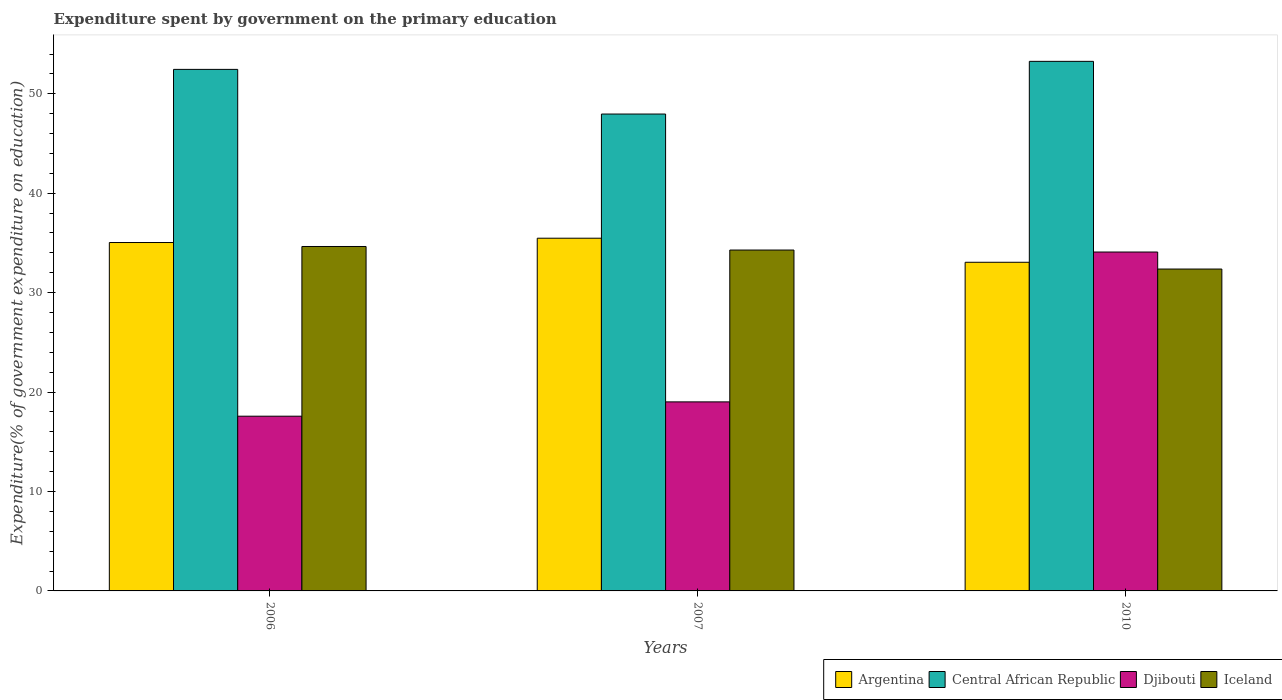How many groups of bars are there?
Keep it short and to the point. 3. Are the number of bars per tick equal to the number of legend labels?
Ensure brevity in your answer.  Yes. How many bars are there on the 2nd tick from the right?
Provide a succinct answer. 4. What is the expenditure spent by government on the primary education in Argentina in 2007?
Offer a very short reply. 35.48. Across all years, what is the maximum expenditure spent by government on the primary education in Argentina?
Provide a short and direct response. 35.48. Across all years, what is the minimum expenditure spent by government on the primary education in Argentina?
Give a very brief answer. 33.05. In which year was the expenditure spent by government on the primary education in Iceland maximum?
Provide a succinct answer. 2006. What is the total expenditure spent by government on the primary education in Central African Republic in the graph?
Provide a succinct answer. 153.69. What is the difference between the expenditure spent by government on the primary education in Argentina in 2006 and that in 2010?
Offer a terse response. 1.99. What is the difference between the expenditure spent by government on the primary education in Djibouti in 2010 and the expenditure spent by government on the primary education in Central African Republic in 2006?
Make the answer very short. -18.37. What is the average expenditure spent by government on the primary education in Iceland per year?
Keep it short and to the point. 33.77. In the year 2006, what is the difference between the expenditure spent by government on the primary education in Argentina and expenditure spent by government on the primary education in Iceland?
Provide a succinct answer. 0.4. What is the ratio of the expenditure spent by government on the primary education in Central African Republic in 2006 to that in 2007?
Ensure brevity in your answer.  1.09. Is the expenditure spent by government on the primary education in Argentina in 2006 less than that in 2010?
Offer a very short reply. No. Is the difference between the expenditure spent by government on the primary education in Argentina in 2007 and 2010 greater than the difference between the expenditure spent by government on the primary education in Iceland in 2007 and 2010?
Provide a succinct answer. Yes. What is the difference between the highest and the second highest expenditure spent by government on the primary education in Argentina?
Make the answer very short. 0.43. What is the difference between the highest and the lowest expenditure spent by government on the primary education in Djibouti?
Your answer should be very brief. 16.51. Is the sum of the expenditure spent by government on the primary education in Central African Republic in 2006 and 2010 greater than the maximum expenditure spent by government on the primary education in Djibouti across all years?
Your answer should be very brief. Yes. What does the 2nd bar from the left in 2010 represents?
Your response must be concise. Central African Republic. What does the 4th bar from the right in 2007 represents?
Your response must be concise. Argentina. How many years are there in the graph?
Your answer should be compact. 3. What is the difference between two consecutive major ticks on the Y-axis?
Provide a short and direct response. 10. Are the values on the major ticks of Y-axis written in scientific E-notation?
Give a very brief answer. No. Does the graph contain grids?
Provide a succinct answer. No. How many legend labels are there?
Provide a succinct answer. 4. What is the title of the graph?
Make the answer very short. Expenditure spent by government on the primary education. Does "Greenland" appear as one of the legend labels in the graph?
Your answer should be very brief. No. What is the label or title of the X-axis?
Ensure brevity in your answer.  Years. What is the label or title of the Y-axis?
Offer a terse response. Expenditure(% of government expenditure on education). What is the Expenditure(% of government expenditure on education) in Argentina in 2006?
Your answer should be compact. 35.04. What is the Expenditure(% of government expenditure on education) in Central African Republic in 2006?
Offer a terse response. 52.46. What is the Expenditure(% of government expenditure on education) in Djibouti in 2006?
Offer a terse response. 17.57. What is the Expenditure(% of government expenditure on education) of Iceland in 2006?
Ensure brevity in your answer.  34.64. What is the Expenditure(% of government expenditure on education) in Argentina in 2007?
Ensure brevity in your answer.  35.48. What is the Expenditure(% of government expenditure on education) of Central African Republic in 2007?
Keep it short and to the point. 47.96. What is the Expenditure(% of government expenditure on education) of Djibouti in 2007?
Offer a very short reply. 19.01. What is the Expenditure(% of government expenditure on education) in Iceland in 2007?
Your answer should be very brief. 34.29. What is the Expenditure(% of government expenditure on education) of Argentina in 2010?
Offer a very short reply. 33.05. What is the Expenditure(% of government expenditure on education) of Central African Republic in 2010?
Your answer should be very brief. 53.26. What is the Expenditure(% of government expenditure on education) of Djibouti in 2010?
Give a very brief answer. 34.09. What is the Expenditure(% of government expenditure on education) of Iceland in 2010?
Offer a very short reply. 32.38. Across all years, what is the maximum Expenditure(% of government expenditure on education) in Argentina?
Ensure brevity in your answer.  35.48. Across all years, what is the maximum Expenditure(% of government expenditure on education) of Central African Republic?
Your response must be concise. 53.26. Across all years, what is the maximum Expenditure(% of government expenditure on education) of Djibouti?
Your answer should be very brief. 34.09. Across all years, what is the maximum Expenditure(% of government expenditure on education) in Iceland?
Your answer should be compact. 34.64. Across all years, what is the minimum Expenditure(% of government expenditure on education) in Argentina?
Your answer should be very brief. 33.05. Across all years, what is the minimum Expenditure(% of government expenditure on education) of Central African Republic?
Provide a succinct answer. 47.96. Across all years, what is the minimum Expenditure(% of government expenditure on education) in Djibouti?
Offer a very short reply. 17.57. Across all years, what is the minimum Expenditure(% of government expenditure on education) in Iceland?
Ensure brevity in your answer.  32.38. What is the total Expenditure(% of government expenditure on education) of Argentina in the graph?
Keep it short and to the point. 103.57. What is the total Expenditure(% of government expenditure on education) in Central African Republic in the graph?
Offer a terse response. 153.69. What is the total Expenditure(% of government expenditure on education) in Djibouti in the graph?
Provide a short and direct response. 70.67. What is the total Expenditure(% of government expenditure on education) in Iceland in the graph?
Your answer should be compact. 101.3. What is the difference between the Expenditure(% of government expenditure on education) in Argentina in 2006 and that in 2007?
Make the answer very short. -0.43. What is the difference between the Expenditure(% of government expenditure on education) of Central African Republic in 2006 and that in 2007?
Provide a succinct answer. 4.49. What is the difference between the Expenditure(% of government expenditure on education) of Djibouti in 2006 and that in 2007?
Provide a succinct answer. -1.44. What is the difference between the Expenditure(% of government expenditure on education) of Iceland in 2006 and that in 2007?
Provide a short and direct response. 0.36. What is the difference between the Expenditure(% of government expenditure on education) in Argentina in 2006 and that in 2010?
Ensure brevity in your answer.  1.99. What is the difference between the Expenditure(% of government expenditure on education) in Central African Republic in 2006 and that in 2010?
Give a very brief answer. -0.81. What is the difference between the Expenditure(% of government expenditure on education) of Djibouti in 2006 and that in 2010?
Ensure brevity in your answer.  -16.51. What is the difference between the Expenditure(% of government expenditure on education) in Iceland in 2006 and that in 2010?
Offer a terse response. 2.27. What is the difference between the Expenditure(% of government expenditure on education) in Argentina in 2007 and that in 2010?
Keep it short and to the point. 2.42. What is the difference between the Expenditure(% of government expenditure on education) in Central African Republic in 2007 and that in 2010?
Ensure brevity in your answer.  -5.3. What is the difference between the Expenditure(% of government expenditure on education) in Djibouti in 2007 and that in 2010?
Your answer should be compact. -15.07. What is the difference between the Expenditure(% of government expenditure on education) in Iceland in 2007 and that in 2010?
Your answer should be very brief. 1.91. What is the difference between the Expenditure(% of government expenditure on education) in Argentina in 2006 and the Expenditure(% of government expenditure on education) in Central African Republic in 2007?
Provide a succinct answer. -12.92. What is the difference between the Expenditure(% of government expenditure on education) of Argentina in 2006 and the Expenditure(% of government expenditure on education) of Djibouti in 2007?
Your response must be concise. 16.03. What is the difference between the Expenditure(% of government expenditure on education) of Argentina in 2006 and the Expenditure(% of government expenditure on education) of Iceland in 2007?
Offer a terse response. 0.76. What is the difference between the Expenditure(% of government expenditure on education) in Central African Republic in 2006 and the Expenditure(% of government expenditure on education) in Djibouti in 2007?
Keep it short and to the point. 33.44. What is the difference between the Expenditure(% of government expenditure on education) in Central African Republic in 2006 and the Expenditure(% of government expenditure on education) in Iceland in 2007?
Make the answer very short. 18.17. What is the difference between the Expenditure(% of government expenditure on education) in Djibouti in 2006 and the Expenditure(% of government expenditure on education) in Iceland in 2007?
Provide a succinct answer. -16.71. What is the difference between the Expenditure(% of government expenditure on education) of Argentina in 2006 and the Expenditure(% of government expenditure on education) of Central African Republic in 2010?
Your response must be concise. -18.22. What is the difference between the Expenditure(% of government expenditure on education) of Argentina in 2006 and the Expenditure(% of government expenditure on education) of Djibouti in 2010?
Offer a terse response. 0.96. What is the difference between the Expenditure(% of government expenditure on education) in Argentina in 2006 and the Expenditure(% of government expenditure on education) in Iceland in 2010?
Offer a terse response. 2.67. What is the difference between the Expenditure(% of government expenditure on education) in Central African Republic in 2006 and the Expenditure(% of government expenditure on education) in Djibouti in 2010?
Offer a very short reply. 18.37. What is the difference between the Expenditure(% of government expenditure on education) of Central African Republic in 2006 and the Expenditure(% of government expenditure on education) of Iceland in 2010?
Make the answer very short. 20.08. What is the difference between the Expenditure(% of government expenditure on education) in Djibouti in 2006 and the Expenditure(% of government expenditure on education) in Iceland in 2010?
Offer a terse response. -14.8. What is the difference between the Expenditure(% of government expenditure on education) in Argentina in 2007 and the Expenditure(% of government expenditure on education) in Central African Republic in 2010?
Your response must be concise. -17.79. What is the difference between the Expenditure(% of government expenditure on education) of Argentina in 2007 and the Expenditure(% of government expenditure on education) of Djibouti in 2010?
Ensure brevity in your answer.  1.39. What is the difference between the Expenditure(% of government expenditure on education) in Argentina in 2007 and the Expenditure(% of government expenditure on education) in Iceland in 2010?
Provide a succinct answer. 3.1. What is the difference between the Expenditure(% of government expenditure on education) in Central African Republic in 2007 and the Expenditure(% of government expenditure on education) in Djibouti in 2010?
Your answer should be very brief. 13.88. What is the difference between the Expenditure(% of government expenditure on education) in Central African Republic in 2007 and the Expenditure(% of government expenditure on education) in Iceland in 2010?
Your answer should be very brief. 15.59. What is the difference between the Expenditure(% of government expenditure on education) of Djibouti in 2007 and the Expenditure(% of government expenditure on education) of Iceland in 2010?
Keep it short and to the point. -13.36. What is the average Expenditure(% of government expenditure on education) of Argentina per year?
Your answer should be very brief. 34.52. What is the average Expenditure(% of government expenditure on education) of Central African Republic per year?
Your response must be concise. 51.23. What is the average Expenditure(% of government expenditure on education) of Djibouti per year?
Provide a succinct answer. 23.56. What is the average Expenditure(% of government expenditure on education) in Iceland per year?
Your answer should be compact. 33.77. In the year 2006, what is the difference between the Expenditure(% of government expenditure on education) of Argentina and Expenditure(% of government expenditure on education) of Central African Republic?
Give a very brief answer. -17.41. In the year 2006, what is the difference between the Expenditure(% of government expenditure on education) in Argentina and Expenditure(% of government expenditure on education) in Djibouti?
Provide a succinct answer. 17.47. In the year 2006, what is the difference between the Expenditure(% of government expenditure on education) of Argentina and Expenditure(% of government expenditure on education) of Iceland?
Your answer should be compact. 0.4. In the year 2006, what is the difference between the Expenditure(% of government expenditure on education) in Central African Republic and Expenditure(% of government expenditure on education) in Djibouti?
Your response must be concise. 34.88. In the year 2006, what is the difference between the Expenditure(% of government expenditure on education) in Central African Republic and Expenditure(% of government expenditure on education) in Iceland?
Provide a short and direct response. 17.81. In the year 2006, what is the difference between the Expenditure(% of government expenditure on education) in Djibouti and Expenditure(% of government expenditure on education) in Iceland?
Offer a very short reply. -17.07. In the year 2007, what is the difference between the Expenditure(% of government expenditure on education) of Argentina and Expenditure(% of government expenditure on education) of Central African Republic?
Your answer should be compact. -12.49. In the year 2007, what is the difference between the Expenditure(% of government expenditure on education) of Argentina and Expenditure(% of government expenditure on education) of Djibouti?
Offer a very short reply. 16.46. In the year 2007, what is the difference between the Expenditure(% of government expenditure on education) in Argentina and Expenditure(% of government expenditure on education) in Iceland?
Your response must be concise. 1.19. In the year 2007, what is the difference between the Expenditure(% of government expenditure on education) of Central African Republic and Expenditure(% of government expenditure on education) of Djibouti?
Provide a succinct answer. 28.95. In the year 2007, what is the difference between the Expenditure(% of government expenditure on education) in Central African Republic and Expenditure(% of government expenditure on education) in Iceland?
Your response must be concise. 13.68. In the year 2007, what is the difference between the Expenditure(% of government expenditure on education) of Djibouti and Expenditure(% of government expenditure on education) of Iceland?
Your answer should be compact. -15.27. In the year 2010, what is the difference between the Expenditure(% of government expenditure on education) of Argentina and Expenditure(% of government expenditure on education) of Central African Republic?
Make the answer very short. -20.21. In the year 2010, what is the difference between the Expenditure(% of government expenditure on education) in Argentina and Expenditure(% of government expenditure on education) in Djibouti?
Keep it short and to the point. -1.03. In the year 2010, what is the difference between the Expenditure(% of government expenditure on education) of Argentina and Expenditure(% of government expenditure on education) of Iceland?
Your response must be concise. 0.68. In the year 2010, what is the difference between the Expenditure(% of government expenditure on education) of Central African Republic and Expenditure(% of government expenditure on education) of Djibouti?
Keep it short and to the point. 19.18. In the year 2010, what is the difference between the Expenditure(% of government expenditure on education) in Central African Republic and Expenditure(% of government expenditure on education) in Iceland?
Offer a very short reply. 20.89. In the year 2010, what is the difference between the Expenditure(% of government expenditure on education) in Djibouti and Expenditure(% of government expenditure on education) in Iceland?
Provide a succinct answer. 1.71. What is the ratio of the Expenditure(% of government expenditure on education) in Central African Republic in 2006 to that in 2007?
Provide a short and direct response. 1.09. What is the ratio of the Expenditure(% of government expenditure on education) in Djibouti in 2006 to that in 2007?
Ensure brevity in your answer.  0.92. What is the ratio of the Expenditure(% of government expenditure on education) in Iceland in 2006 to that in 2007?
Offer a very short reply. 1.01. What is the ratio of the Expenditure(% of government expenditure on education) of Argentina in 2006 to that in 2010?
Your response must be concise. 1.06. What is the ratio of the Expenditure(% of government expenditure on education) of Central African Republic in 2006 to that in 2010?
Your response must be concise. 0.98. What is the ratio of the Expenditure(% of government expenditure on education) in Djibouti in 2006 to that in 2010?
Make the answer very short. 0.52. What is the ratio of the Expenditure(% of government expenditure on education) in Iceland in 2006 to that in 2010?
Offer a terse response. 1.07. What is the ratio of the Expenditure(% of government expenditure on education) in Argentina in 2007 to that in 2010?
Offer a terse response. 1.07. What is the ratio of the Expenditure(% of government expenditure on education) of Central African Republic in 2007 to that in 2010?
Give a very brief answer. 0.9. What is the ratio of the Expenditure(% of government expenditure on education) of Djibouti in 2007 to that in 2010?
Your response must be concise. 0.56. What is the ratio of the Expenditure(% of government expenditure on education) of Iceland in 2007 to that in 2010?
Make the answer very short. 1.06. What is the difference between the highest and the second highest Expenditure(% of government expenditure on education) in Argentina?
Offer a very short reply. 0.43. What is the difference between the highest and the second highest Expenditure(% of government expenditure on education) in Central African Republic?
Provide a short and direct response. 0.81. What is the difference between the highest and the second highest Expenditure(% of government expenditure on education) of Djibouti?
Offer a terse response. 15.07. What is the difference between the highest and the second highest Expenditure(% of government expenditure on education) in Iceland?
Keep it short and to the point. 0.36. What is the difference between the highest and the lowest Expenditure(% of government expenditure on education) in Argentina?
Ensure brevity in your answer.  2.42. What is the difference between the highest and the lowest Expenditure(% of government expenditure on education) of Central African Republic?
Your answer should be compact. 5.3. What is the difference between the highest and the lowest Expenditure(% of government expenditure on education) of Djibouti?
Give a very brief answer. 16.51. What is the difference between the highest and the lowest Expenditure(% of government expenditure on education) of Iceland?
Offer a very short reply. 2.27. 